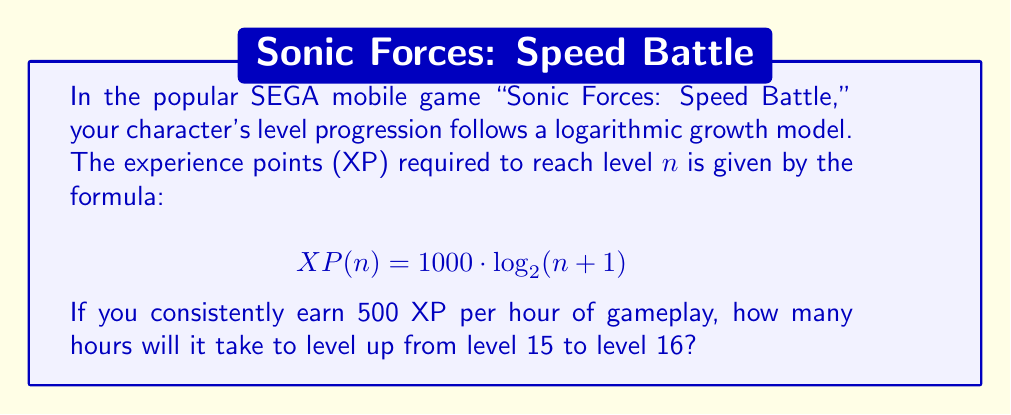Can you solve this math problem? To solve this problem, we need to follow these steps:

1) Calculate the XP required for level 16:
   $$ XP(16) = 1000 \cdot \log_2(16+1) = 1000 \cdot \log_2(17) $$

2) Calculate the XP required for level 15:
   $$ XP(15) = 1000 \cdot \log_2(15+1) = 1000 \cdot \log_2(16) $$

3) Find the difference in XP between these levels:
   $$ \Delta XP = XP(16) - XP(15) = 1000 \cdot (\log_2(17) - \log_2(16)) $$

4) Using the logarithm property $\log_a(x) - \log_a(y) = \log_a(\frac{x}{y})$:
   $$ \Delta XP = 1000 \cdot \log_2(\frac{17}{16}) $$

5) Calculate this value:
   $$ \Delta XP = 1000 \cdot \log_2(1.0625) \approx 87.47 \text{ XP} $$

6) Since you earn 500 XP per hour, divide the required XP by 500 to get the time in hours:
   $$ \text{Time} = \frac{87.47}{500} \approx 0.1749 \text{ hours} $$

7) Convert to minutes:
   $$ 0.1749 \text{ hours} \times 60 \text{ minutes/hour} \approx 10.5 \text{ minutes} $$
Answer: It will take approximately 10.5 minutes to level up from level 15 to level 16. 